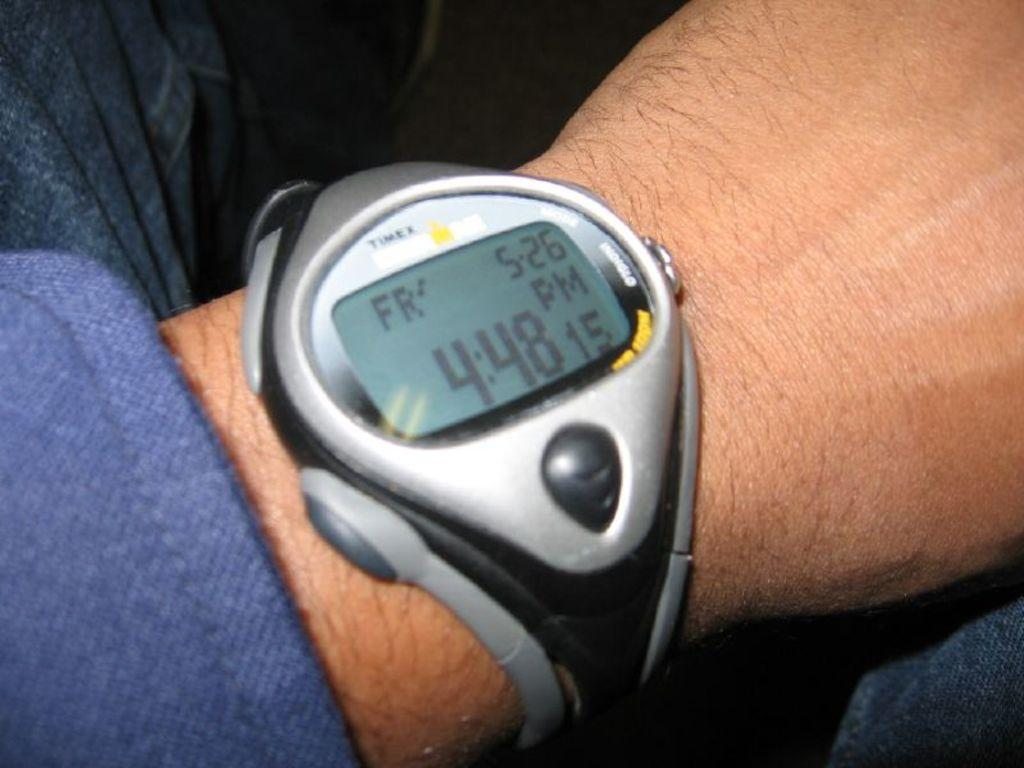<image>
Render a clear and concise summary of the photo. A Timex watch displays the time of 4:48. 